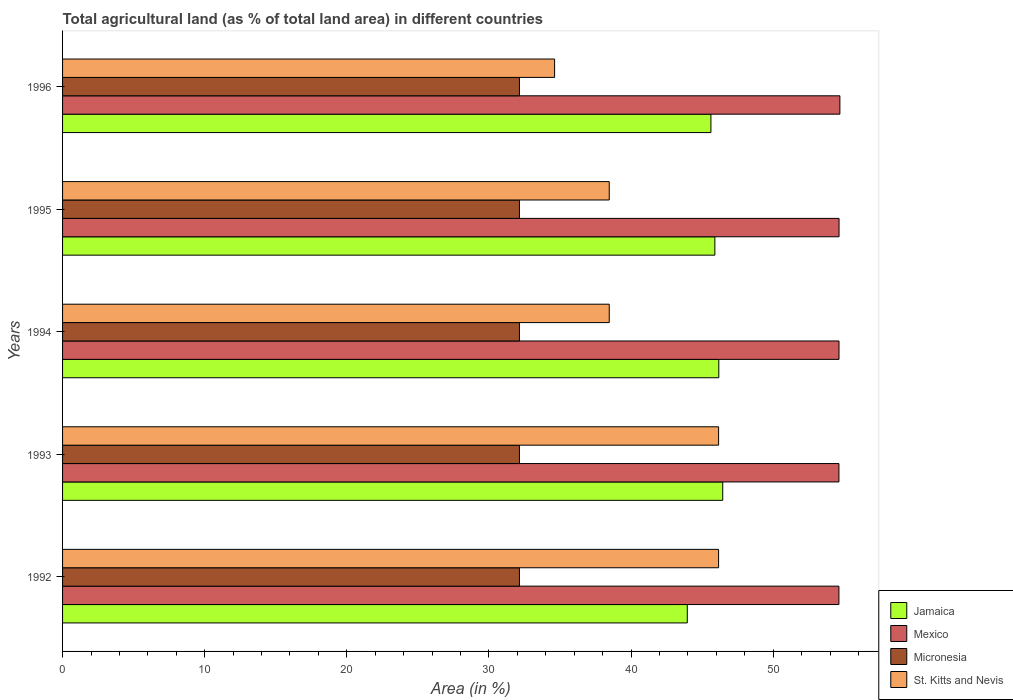How many different coloured bars are there?
Your response must be concise. 4. Are the number of bars per tick equal to the number of legend labels?
Give a very brief answer. Yes. Are the number of bars on each tick of the Y-axis equal?
Your answer should be very brief. Yes. How many bars are there on the 1st tick from the bottom?
Your answer should be very brief. 4. What is the label of the 2nd group of bars from the top?
Keep it short and to the point. 1995. In how many cases, is the number of bars for a given year not equal to the number of legend labels?
Ensure brevity in your answer.  0. What is the percentage of agricultural land in Jamaica in 1996?
Ensure brevity in your answer.  45.61. Across all years, what is the maximum percentage of agricultural land in Mexico?
Provide a succinct answer. 54.69. Across all years, what is the minimum percentage of agricultural land in Mexico?
Your response must be concise. 54.62. In which year was the percentage of agricultural land in Mexico maximum?
Provide a short and direct response. 1996. What is the total percentage of agricultural land in Mexico in the graph?
Provide a succinct answer. 273.18. What is the difference between the percentage of agricultural land in St. Kitts and Nevis in 1993 and that in 1994?
Your answer should be compact. 7.69. What is the difference between the percentage of agricultural land in Jamaica in 1993 and the percentage of agricultural land in Micronesia in 1995?
Ensure brevity in your answer.  14.3. What is the average percentage of agricultural land in Jamaica per year?
Your answer should be very brief. 45.61. In the year 1995, what is the difference between the percentage of agricultural land in Jamaica and percentage of agricultural land in Mexico?
Ensure brevity in your answer.  -8.74. Is the percentage of agricultural land in Jamaica in 1992 less than that in 1996?
Ensure brevity in your answer.  Yes. Is the difference between the percentage of agricultural land in Jamaica in 1993 and 1994 greater than the difference between the percentage of agricultural land in Mexico in 1993 and 1994?
Make the answer very short. Yes. What is the difference between the highest and the second highest percentage of agricultural land in Mexico?
Keep it short and to the point. 0.06. What is the difference between the highest and the lowest percentage of agricultural land in Jamaica?
Make the answer very short. 2.49. Is it the case that in every year, the sum of the percentage of agricultural land in Micronesia and percentage of agricultural land in St. Kitts and Nevis is greater than the sum of percentage of agricultural land in Mexico and percentage of agricultural land in Jamaica?
Make the answer very short. No. What does the 1st bar from the top in 1994 represents?
Offer a very short reply. St. Kitts and Nevis. How many bars are there?
Ensure brevity in your answer.  20. How many years are there in the graph?
Your response must be concise. 5. Does the graph contain any zero values?
Keep it short and to the point. No. Where does the legend appear in the graph?
Offer a terse response. Bottom right. How many legend labels are there?
Give a very brief answer. 4. What is the title of the graph?
Your response must be concise. Total agricultural land (as % of total land area) in different countries. What is the label or title of the X-axis?
Keep it short and to the point. Area (in %). What is the Area (in %) in Jamaica in 1992?
Keep it short and to the point. 43.95. What is the Area (in %) in Mexico in 1992?
Make the answer very short. 54.62. What is the Area (in %) in Micronesia in 1992?
Offer a very short reply. 32.14. What is the Area (in %) of St. Kitts and Nevis in 1992?
Keep it short and to the point. 46.15. What is the Area (in %) of Jamaica in 1993?
Offer a very short reply. 46.45. What is the Area (in %) in Mexico in 1993?
Offer a terse response. 54.62. What is the Area (in %) in Micronesia in 1993?
Your response must be concise. 32.14. What is the Area (in %) of St. Kitts and Nevis in 1993?
Your answer should be compact. 46.15. What is the Area (in %) in Jamaica in 1994?
Provide a succinct answer. 46.17. What is the Area (in %) in Mexico in 1994?
Keep it short and to the point. 54.63. What is the Area (in %) in Micronesia in 1994?
Give a very brief answer. 32.14. What is the Area (in %) of St. Kitts and Nevis in 1994?
Your response must be concise. 38.46. What is the Area (in %) in Jamaica in 1995?
Your response must be concise. 45.89. What is the Area (in %) in Mexico in 1995?
Ensure brevity in your answer.  54.63. What is the Area (in %) of Micronesia in 1995?
Provide a succinct answer. 32.14. What is the Area (in %) in St. Kitts and Nevis in 1995?
Make the answer very short. 38.46. What is the Area (in %) of Jamaica in 1996?
Your response must be concise. 45.61. What is the Area (in %) in Mexico in 1996?
Provide a short and direct response. 54.69. What is the Area (in %) in Micronesia in 1996?
Make the answer very short. 32.14. What is the Area (in %) of St. Kitts and Nevis in 1996?
Keep it short and to the point. 34.62. Across all years, what is the maximum Area (in %) of Jamaica?
Ensure brevity in your answer.  46.45. Across all years, what is the maximum Area (in %) in Mexico?
Offer a very short reply. 54.69. Across all years, what is the maximum Area (in %) in Micronesia?
Provide a short and direct response. 32.14. Across all years, what is the maximum Area (in %) of St. Kitts and Nevis?
Offer a terse response. 46.15. Across all years, what is the minimum Area (in %) of Jamaica?
Give a very brief answer. 43.95. Across all years, what is the minimum Area (in %) of Mexico?
Provide a succinct answer. 54.62. Across all years, what is the minimum Area (in %) of Micronesia?
Provide a succinct answer. 32.14. Across all years, what is the minimum Area (in %) of St. Kitts and Nevis?
Provide a succinct answer. 34.62. What is the total Area (in %) in Jamaica in the graph?
Offer a very short reply. 228.07. What is the total Area (in %) in Mexico in the graph?
Offer a very short reply. 273.18. What is the total Area (in %) in Micronesia in the graph?
Your response must be concise. 160.71. What is the total Area (in %) in St. Kitts and Nevis in the graph?
Your answer should be very brief. 203.85. What is the difference between the Area (in %) in Jamaica in 1992 and that in 1993?
Your answer should be compact. -2.49. What is the difference between the Area (in %) in Mexico in 1992 and that in 1993?
Give a very brief answer. -0. What is the difference between the Area (in %) of Micronesia in 1992 and that in 1993?
Provide a short and direct response. 0. What is the difference between the Area (in %) of Jamaica in 1992 and that in 1994?
Offer a terse response. -2.22. What is the difference between the Area (in %) of Mexico in 1992 and that in 1994?
Offer a very short reply. -0.01. What is the difference between the Area (in %) in Micronesia in 1992 and that in 1994?
Give a very brief answer. 0. What is the difference between the Area (in %) in St. Kitts and Nevis in 1992 and that in 1994?
Ensure brevity in your answer.  7.69. What is the difference between the Area (in %) of Jamaica in 1992 and that in 1995?
Your response must be concise. -1.94. What is the difference between the Area (in %) in Mexico in 1992 and that in 1995?
Provide a short and direct response. -0.01. What is the difference between the Area (in %) of St. Kitts and Nevis in 1992 and that in 1995?
Your answer should be compact. 7.69. What is the difference between the Area (in %) of Jamaica in 1992 and that in 1996?
Give a very brief answer. -1.66. What is the difference between the Area (in %) of Mexico in 1992 and that in 1996?
Offer a very short reply. -0.07. What is the difference between the Area (in %) of St. Kitts and Nevis in 1992 and that in 1996?
Provide a succinct answer. 11.54. What is the difference between the Area (in %) in Jamaica in 1993 and that in 1994?
Ensure brevity in your answer.  0.28. What is the difference between the Area (in %) in Mexico in 1993 and that in 1994?
Offer a very short reply. -0.01. What is the difference between the Area (in %) in Micronesia in 1993 and that in 1994?
Your answer should be very brief. 0. What is the difference between the Area (in %) in St. Kitts and Nevis in 1993 and that in 1994?
Provide a short and direct response. 7.69. What is the difference between the Area (in %) of Jamaica in 1993 and that in 1995?
Provide a succinct answer. 0.55. What is the difference between the Area (in %) in Mexico in 1993 and that in 1995?
Ensure brevity in your answer.  -0.01. What is the difference between the Area (in %) of Micronesia in 1993 and that in 1995?
Your answer should be compact. 0. What is the difference between the Area (in %) in St. Kitts and Nevis in 1993 and that in 1995?
Give a very brief answer. 7.69. What is the difference between the Area (in %) in Jamaica in 1993 and that in 1996?
Your answer should be compact. 0.83. What is the difference between the Area (in %) in Mexico in 1993 and that in 1996?
Your answer should be very brief. -0.07. What is the difference between the Area (in %) in Micronesia in 1993 and that in 1996?
Ensure brevity in your answer.  0. What is the difference between the Area (in %) of St. Kitts and Nevis in 1993 and that in 1996?
Keep it short and to the point. 11.54. What is the difference between the Area (in %) of Jamaica in 1994 and that in 1995?
Keep it short and to the point. 0.28. What is the difference between the Area (in %) in Mexico in 1994 and that in 1995?
Keep it short and to the point. -0. What is the difference between the Area (in %) in Micronesia in 1994 and that in 1995?
Offer a very short reply. 0. What is the difference between the Area (in %) of Jamaica in 1994 and that in 1996?
Provide a succinct answer. 0.55. What is the difference between the Area (in %) in Mexico in 1994 and that in 1996?
Keep it short and to the point. -0.06. What is the difference between the Area (in %) in St. Kitts and Nevis in 1994 and that in 1996?
Your answer should be compact. 3.85. What is the difference between the Area (in %) in Jamaica in 1995 and that in 1996?
Offer a very short reply. 0.28. What is the difference between the Area (in %) of Mexico in 1995 and that in 1996?
Make the answer very short. -0.06. What is the difference between the Area (in %) in Micronesia in 1995 and that in 1996?
Your response must be concise. 0. What is the difference between the Area (in %) of St. Kitts and Nevis in 1995 and that in 1996?
Keep it short and to the point. 3.85. What is the difference between the Area (in %) in Jamaica in 1992 and the Area (in %) in Mexico in 1993?
Provide a succinct answer. -10.67. What is the difference between the Area (in %) in Jamaica in 1992 and the Area (in %) in Micronesia in 1993?
Keep it short and to the point. 11.81. What is the difference between the Area (in %) of Jamaica in 1992 and the Area (in %) of St. Kitts and Nevis in 1993?
Your answer should be compact. -2.2. What is the difference between the Area (in %) in Mexico in 1992 and the Area (in %) in Micronesia in 1993?
Ensure brevity in your answer.  22.48. What is the difference between the Area (in %) of Mexico in 1992 and the Area (in %) of St. Kitts and Nevis in 1993?
Your answer should be compact. 8.47. What is the difference between the Area (in %) in Micronesia in 1992 and the Area (in %) in St. Kitts and Nevis in 1993?
Provide a succinct answer. -14.01. What is the difference between the Area (in %) in Jamaica in 1992 and the Area (in %) in Mexico in 1994?
Offer a very short reply. -10.67. What is the difference between the Area (in %) in Jamaica in 1992 and the Area (in %) in Micronesia in 1994?
Keep it short and to the point. 11.81. What is the difference between the Area (in %) in Jamaica in 1992 and the Area (in %) in St. Kitts and Nevis in 1994?
Provide a short and direct response. 5.49. What is the difference between the Area (in %) of Mexico in 1992 and the Area (in %) of Micronesia in 1994?
Keep it short and to the point. 22.48. What is the difference between the Area (in %) of Mexico in 1992 and the Area (in %) of St. Kitts and Nevis in 1994?
Make the answer very short. 16.16. What is the difference between the Area (in %) of Micronesia in 1992 and the Area (in %) of St. Kitts and Nevis in 1994?
Offer a very short reply. -6.32. What is the difference between the Area (in %) in Jamaica in 1992 and the Area (in %) in Mexico in 1995?
Provide a short and direct response. -10.68. What is the difference between the Area (in %) in Jamaica in 1992 and the Area (in %) in Micronesia in 1995?
Your answer should be very brief. 11.81. What is the difference between the Area (in %) of Jamaica in 1992 and the Area (in %) of St. Kitts and Nevis in 1995?
Keep it short and to the point. 5.49. What is the difference between the Area (in %) of Mexico in 1992 and the Area (in %) of Micronesia in 1995?
Offer a very short reply. 22.48. What is the difference between the Area (in %) in Mexico in 1992 and the Area (in %) in St. Kitts and Nevis in 1995?
Give a very brief answer. 16.16. What is the difference between the Area (in %) of Micronesia in 1992 and the Area (in %) of St. Kitts and Nevis in 1995?
Your response must be concise. -6.32. What is the difference between the Area (in %) of Jamaica in 1992 and the Area (in %) of Mexico in 1996?
Offer a terse response. -10.74. What is the difference between the Area (in %) of Jamaica in 1992 and the Area (in %) of Micronesia in 1996?
Offer a very short reply. 11.81. What is the difference between the Area (in %) in Jamaica in 1992 and the Area (in %) in St. Kitts and Nevis in 1996?
Your response must be concise. 9.34. What is the difference between the Area (in %) of Mexico in 1992 and the Area (in %) of Micronesia in 1996?
Give a very brief answer. 22.48. What is the difference between the Area (in %) in Mexico in 1992 and the Area (in %) in St. Kitts and Nevis in 1996?
Your answer should be compact. 20. What is the difference between the Area (in %) in Micronesia in 1992 and the Area (in %) in St. Kitts and Nevis in 1996?
Give a very brief answer. -2.47. What is the difference between the Area (in %) in Jamaica in 1993 and the Area (in %) in Mexico in 1994?
Keep it short and to the point. -8.18. What is the difference between the Area (in %) in Jamaica in 1993 and the Area (in %) in Micronesia in 1994?
Offer a terse response. 14.3. What is the difference between the Area (in %) in Jamaica in 1993 and the Area (in %) in St. Kitts and Nevis in 1994?
Make the answer very short. 7.98. What is the difference between the Area (in %) of Mexico in 1993 and the Area (in %) of Micronesia in 1994?
Offer a terse response. 22.48. What is the difference between the Area (in %) of Mexico in 1993 and the Area (in %) of St. Kitts and Nevis in 1994?
Make the answer very short. 16.16. What is the difference between the Area (in %) of Micronesia in 1993 and the Area (in %) of St. Kitts and Nevis in 1994?
Make the answer very short. -6.32. What is the difference between the Area (in %) in Jamaica in 1993 and the Area (in %) in Mexico in 1995?
Make the answer very short. -8.18. What is the difference between the Area (in %) of Jamaica in 1993 and the Area (in %) of Micronesia in 1995?
Give a very brief answer. 14.3. What is the difference between the Area (in %) of Jamaica in 1993 and the Area (in %) of St. Kitts and Nevis in 1995?
Make the answer very short. 7.98. What is the difference between the Area (in %) in Mexico in 1993 and the Area (in %) in Micronesia in 1995?
Offer a very short reply. 22.48. What is the difference between the Area (in %) of Mexico in 1993 and the Area (in %) of St. Kitts and Nevis in 1995?
Your answer should be compact. 16.16. What is the difference between the Area (in %) of Micronesia in 1993 and the Area (in %) of St. Kitts and Nevis in 1995?
Make the answer very short. -6.32. What is the difference between the Area (in %) in Jamaica in 1993 and the Area (in %) in Mexico in 1996?
Ensure brevity in your answer.  -8.24. What is the difference between the Area (in %) of Jamaica in 1993 and the Area (in %) of Micronesia in 1996?
Ensure brevity in your answer.  14.3. What is the difference between the Area (in %) in Jamaica in 1993 and the Area (in %) in St. Kitts and Nevis in 1996?
Offer a terse response. 11.83. What is the difference between the Area (in %) of Mexico in 1993 and the Area (in %) of Micronesia in 1996?
Offer a very short reply. 22.48. What is the difference between the Area (in %) in Mexico in 1993 and the Area (in %) in St. Kitts and Nevis in 1996?
Make the answer very short. 20.01. What is the difference between the Area (in %) of Micronesia in 1993 and the Area (in %) of St. Kitts and Nevis in 1996?
Make the answer very short. -2.47. What is the difference between the Area (in %) of Jamaica in 1994 and the Area (in %) of Mexico in 1995?
Offer a very short reply. -8.46. What is the difference between the Area (in %) in Jamaica in 1994 and the Area (in %) in Micronesia in 1995?
Keep it short and to the point. 14.03. What is the difference between the Area (in %) of Jamaica in 1994 and the Area (in %) of St. Kitts and Nevis in 1995?
Provide a succinct answer. 7.71. What is the difference between the Area (in %) of Mexico in 1994 and the Area (in %) of Micronesia in 1995?
Provide a succinct answer. 22.48. What is the difference between the Area (in %) in Mexico in 1994 and the Area (in %) in St. Kitts and Nevis in 1995?
Give a very brief answer. 16.16. What is the difference between the Area (in %) in Micronesia in 1994 and the Area (in %) in St. Kitts and Nevis in 1995?
Your answer should be compact. -6.32. What is the difference between the Area (in %) in Jamaica in 1994 and the Area (in %) in Mexico in 1996?
Provide a succinct answer. -8.52. What is the difference between the Area (in %) in Jamaica in 1994 and the Area (in %) in Micronesia in 1996?
Give a very brief answer. 14.03. What is the difference between the Area (in %) in Jamaica in 1994 and the Area (in %) in St. Kitts and Nevis in 1996?
Your answer should be compact. 11.55. What is the difference between the Area (in %) in Mexico in 1994 and the Area (in %) in Micronesia in 1996?
Offer a terse response. 22.48. What is the difference between the Area (in %) in Mexico in 1994 and the Area (in %) in St. Kitts and Nevis in 1996?
Make the answer very short. 20.01. What is the difference between the Area (in %) in Micronesia in 1994 and the Area (in %) in St. Kitts and Nevis in 1996?
Give a very brief answer. -2.47. What is the difference between the Area (in %) of Jamaica in 1995 and the Area (in %) of Mexico in 1996?
Keep it short and to the point. -8.8. What is the difference between the Area (in %) of Jamaica in 1995 and the Area (in %) of Micronesia in 1996?
Give a very brief answer. 13.75. What is the difference between the Area (in %) in Jamaica in 1995 and the Area (in %) in St. Kitts and Nevis in 1996?
Offer a very short reply. 11.28. What is the difference between the Area (in %) of Mexico in 1995 and the Area (in %) of Micronesia in 1996?
Make the answer very short. 22.49. What is the difference between the Area (in %) of Mexico in 1995 and the Area (in %) of St. Kitts and Nevis in 1996?
Offer a very short reply. 20.01. What is the difference between the Area (in %) of Micronesia in 1995 and the Area (in %) of St. Kitts and Nevis in 1996?
Your answer should be very brief. -2.47. What is the average Area (in %) in Jamaica per year?
Ensure brevity in your answer.  45.61. What is the average Area (in %) in Mexico per year?
Make the answer very short. 54.64. What is the average Area (in %) of Micronesia per year?
Offer a terse response. 32.14. What is the average Area (in %) in St. Kitts and Nevis per year?
Ensure brevity in your answer.  40.77. In the year 1992, what is the difference between the Area (in %) of Jamaica and Area (in %) of Mexico?
Keep it short and to the point. -10.67. In the year 1992, what is the difference between the Area (in %) of Jamaica and Area (in %) of Micronesia?
Your answer should be compact. 11.81. In the year 1992, what is the difference between the Area (in %) of Jamaica and Area (in %) of St. Kitts and Nevis?
Your response must be concise. -2.2. In the year 1992, what is the difference between the Area (in %) in Mexico and Area (in %) in Micronesia?
Make the answer very short. 22.48. In the year 1992, what is the difference between the Area (in %) in Mexico and Area (in %) in St. Kitts and Nevis?
Keep it short and to the point. 8.47. In the year 1992, what is the difference between the Area (in %) of Micronesia and Area (in %) of St. Kitts and Nevis?
Ensure brevity in your answer.  -14.01. In the year 1993, what is the difference between the Area (in %) in Jamaica and Area (in %) in Mexico?
Provide a succinct answer. -8.18. In the year 1993, what is the difference between the Area (in %) of Jamaica and Area (in %) of Micronesia?
Offer a terse response. 14.3. In the year 1993, what is the difference between the Area (in %) of Jamaica and Area (in %) of St. Kitts and Nevis?
Give a very brief answer. 0.29. In the year 1993, what is the difference between the Area (in %) of Mexico and Area (in %) of Micronesia?
Your answer should be very brief. 22.48. In the year 1993, what is the difference between the Area (in %) of Mexico and Area (in %) of St. Kitts and Nevis?
Provide a succinct answer. 8.47. In the year 1993, what is the difference between the Area (in %) in Micronesia and Area (in %) in St. Kitts and Nevis?
Ensure brevity in your answer.  -14.01. In the year 1994, what is the difference between the Area (in %) of Jamaica and Area (in %) of Mexico?
Your answer should be compact. -8.46. In the year 1994, what is the difference between the Area (in %) of Jamaica and Area (in %) of Micronesia?
Your response must be concise. 14.03. In the year 1994, what is the difference between the Area (in %) of Jamaica and Area (in %) of St. Kitts and Nevis?
Ensure brevity in your answer.  7.71. In the year 1994, what is the difference between the Area (in %) in Mexico and Area (in %) in Micronesia?
Your answer should be very brief. 22.48. In the year 1994, what is the difference between the Area (in %) in Mexico and Area (in %) in St. Kitts and Nevis?
Your answer should be very brief. 16.16. In the year 1994, what is the difference between the Area (in %) in Micronesia and Area (in %) in St. Kitts and Nevis?
Provide a short and direct response. -6.32. In the year 1995, what is the difference between the Area (in %) in Jamaica and Area (in %) in Mexico?
Provide a short and direct response. -8.74. In the year 1995, what is the difference between the Area (in %) of Jamaica and Area (in %) of Micronesia?
Offer a terse response. 13.75. In the year 1995, what is the difference between the Area (in %) of Jamaica and Area (in %) of St. Kitts and Nevis?
Provide a short and direct response. 7.43. In the year 1995, what is the difference between the Area (in %) of Mexico and Area (in %) of Micronesia?
Your answer should be very brief. 22.49. In the year 1995, what is the difference between the Area (in %) in Mexico and Area (in %) in St. Kitts and Nevis?
Your response must be concise. 16.17. In the year 1995, what is the difference between the Area (in %) in Micronesia and Area (in %) in St. Kitts and Nevis?
Your answer should be compact. -6.32. In the year 1996, what is the difference between the Area (in %) in Jamaica and Area (in %) in Mexico?
Provide a short and direct response. -9.07. In the year 1996, what is the difference between the Area (in %) in Jamaica and Area (in %) in Micronesia?
Offer a terse response. 13.47. In the year 1996, what is the difference between the Area (in %) in Jamaica and Area (in %) in St. Kitts and Nevis?
Offer a terse response. 11. In the year 1996, what is the difference between the Area (in %) of Mexico and Area (in %) of Micronesia?
Provide a short and direct response. 22.54. In the year 1996, what is the difference between the Area (in %) of Mexico and Area (in %) of St. Kitts and Nevis?
Provide a succinct answer. 20.07. In the year 1996, what is the difference between the Area (in %) in Micronesia and Area (in %) in St. Kitts and Nevis?
Ensure brevity in your answer.  -2.47. What is the ratio of the Area (in %) in Jamaica in 1992 to that in 1993?
Your response must be concise. 0.95. What is the ratio of the Area (in %) of Micronesia in 1992 to that in 1993?
Offer a terse response. 1. What is the ratio of the Area (in %) in Micronesia in 1992 to that in 1994?
Ensure brevity in your answer.  1. What is the ratio of the Area (in %) of Jamaica in 1992 to that in 1995?
Keep it short and to the point. 0.96. What is the ratio of the Area (in %) of Micronesia in 1992 to that in 1995?
Provide a short and direct response. 1. What is the ratio of the Area (in %) in Jamaica in 1992 to that in 1996?
Offer a terse response. 0.96. What is the ratio of the Area (in %) of Jamaica in 1993 to that in 1994?
Make the answer very short. 1.01. What is the ratio of the Area (in %) in Mexico in 1993 to that in 1994?
Provide a short and direct response. 1. What is the ratio of the Area (in %) of St. Kitts and Nevis in 1993 to that in 1994?
Your answer should be compact. 1.2. What is the ratio of the Area (in %) in Jamaica in 1993 to that in 1995?
Your answer should be compact. 1.01. What is the ratio of the Area (in %) in Micronesia in 1993 to that in 1995?
Provide a succinct answer. 1. What is the ratio of the Area (in %) of Jamaica in 1993 to that in 1996?
Provide a succinct answer. 1.02. What is the ratio of the Area (in %) of Micronesia in 1993 to that in 1996?
Ensure brevity in your answer.  1. What is the ratio of the Area (in %) of St. Kitts and Nevis in 1993 to that in 1996?
Provide a succinct answer. 1.33. What is the ratio of the Area (in %) in Micronesia in 1994 to that in 1995?
Give a very brief answer. 1. What is the ratio of the Area (in %) of Jamaica in 1994 to that in 1996?
Provide a short and direct response. 1.01. What is the ratio of the Area (in %) of Mexico in 1995 to that in 1996?
Offer a very short reply. 1. What is the difference between the highest and the second highest Area (in %) of Jamaica?
Keep it short and to the point. 0.28. What is the difference between the highest and the second highest Area (in %) of Mexico?
Your answer should be very brief. 0.06. What is the difference between the highest and the lowest Area (in %) of Jamaica?
Provide a succinct answer. 2.49. What is the difference between the highest and the lowest Area (in %) of Mexico?
Make the answer very short. 0.07. What is the difference between the highest and the lowest Area (in %) of Micronesia?
Ensure brevity in your answer.  0. What is the difference between the highest and the lowest Area (in %) in St. Kitts and Nevis?
Ensure brevity in your answer.  11.54. 